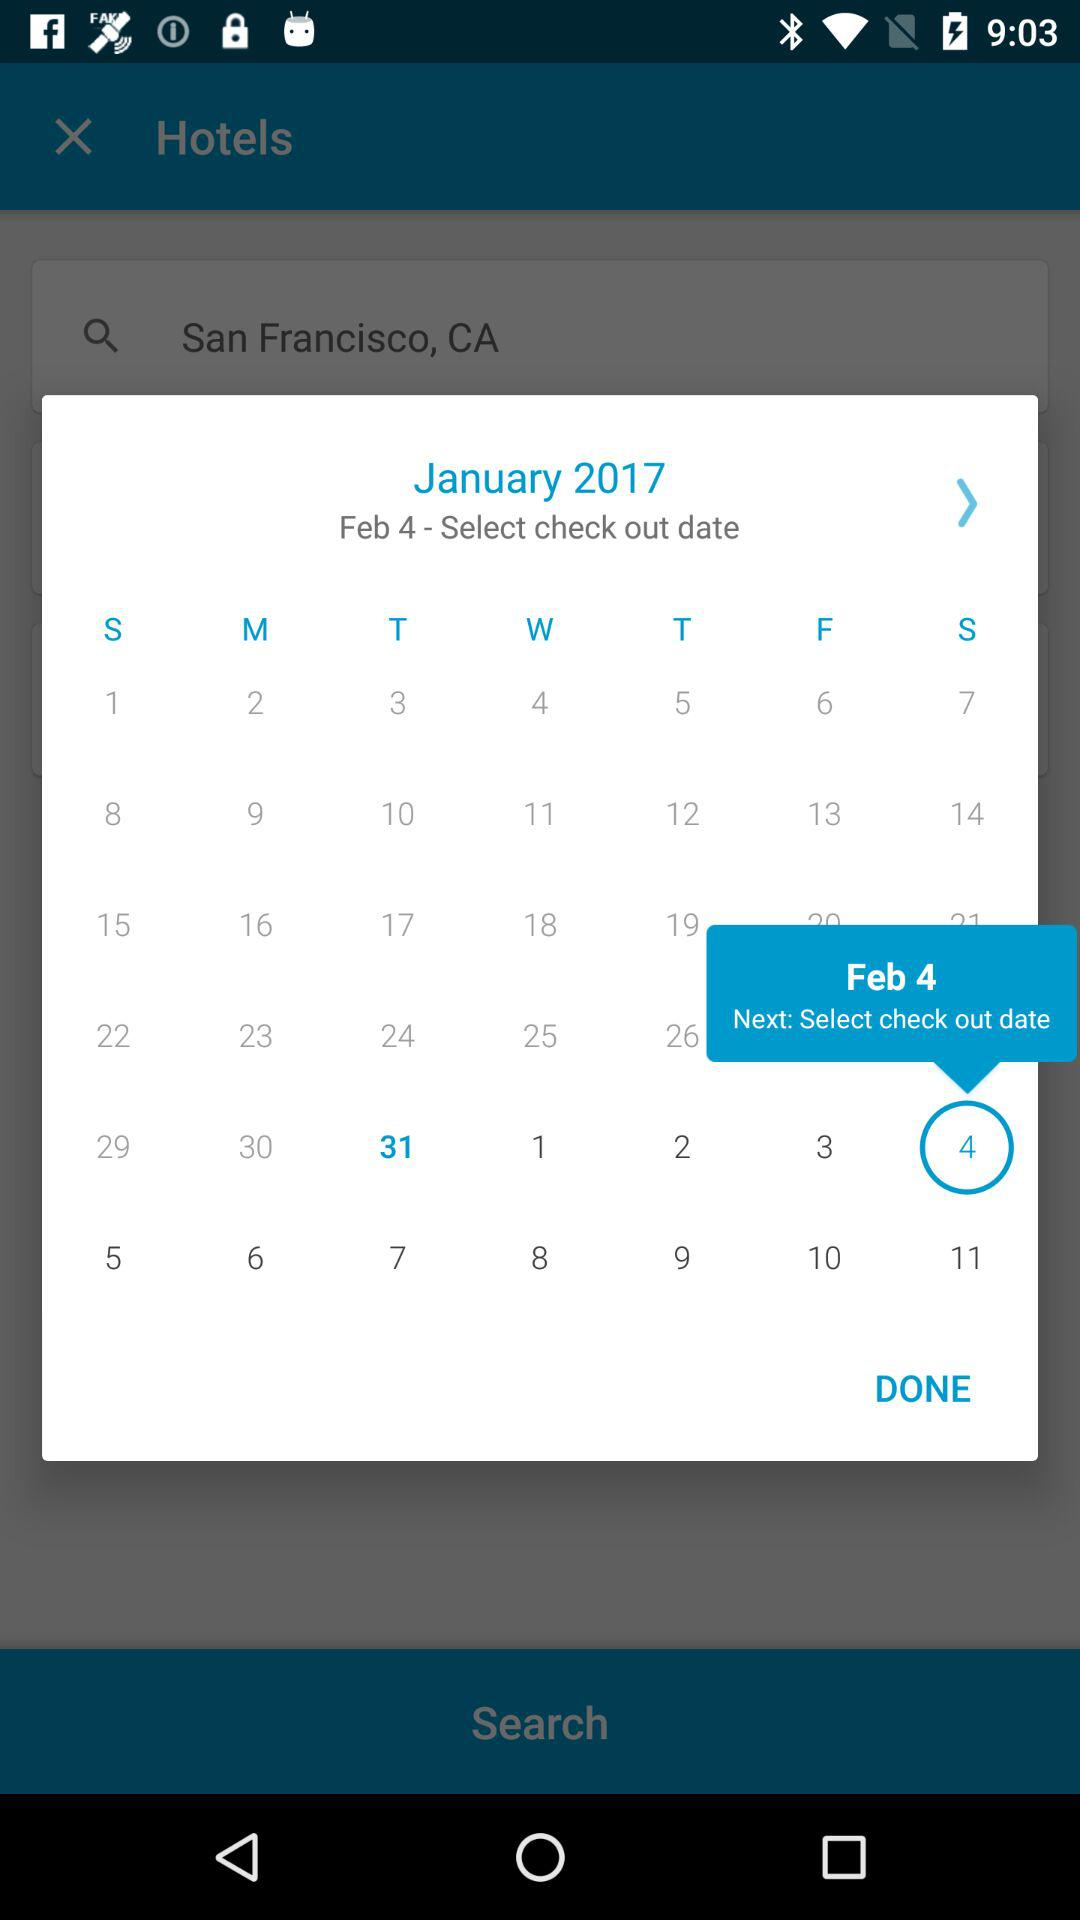What is the day on the selected date? The day is Saturday. 